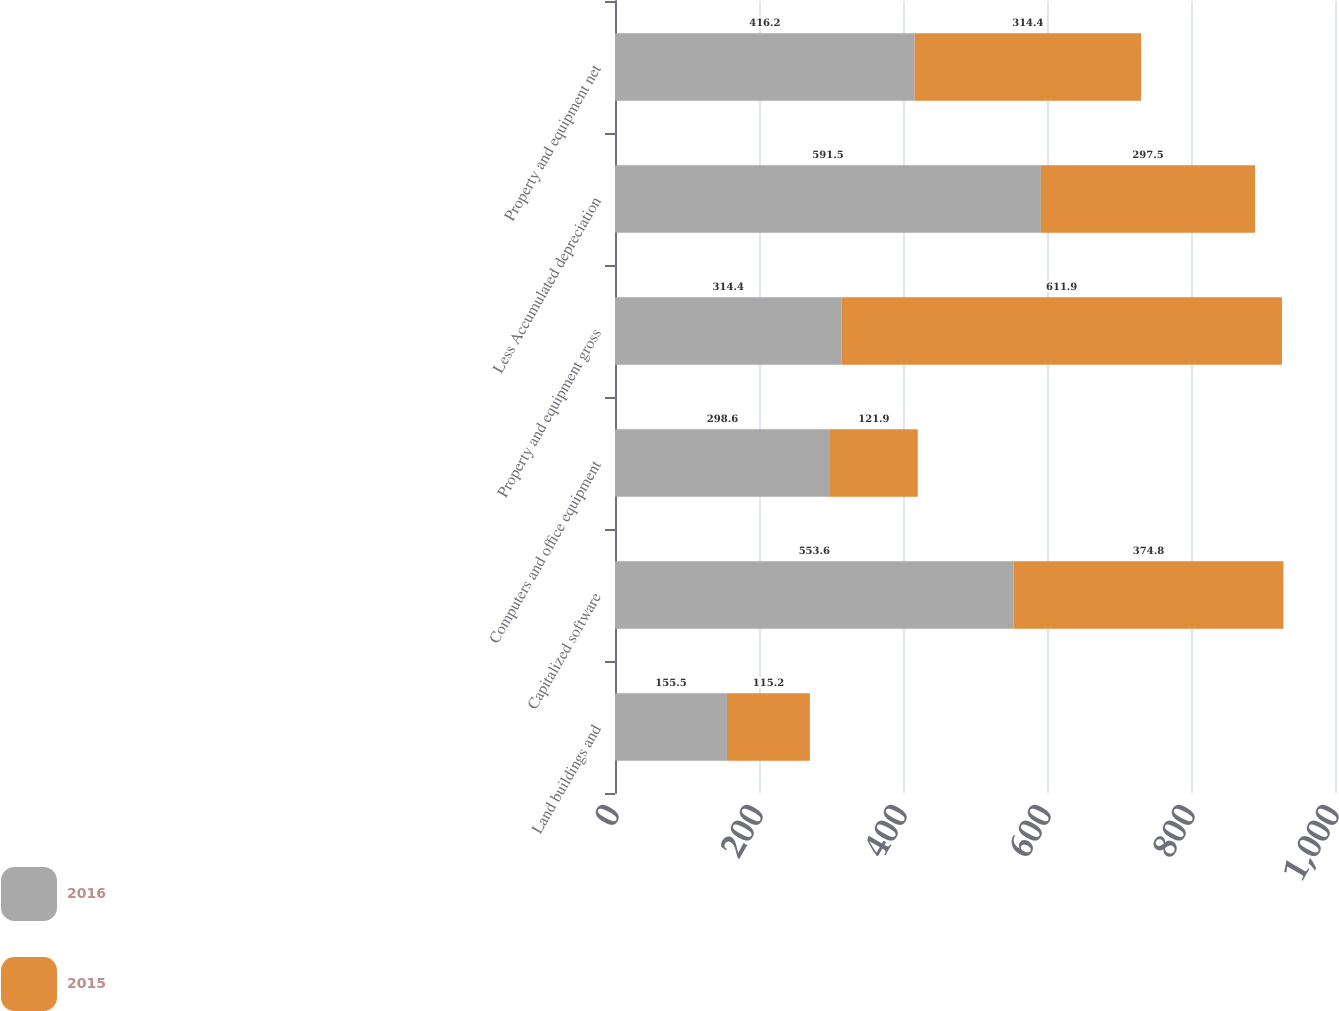Convert chart. <chart><loc_0><loc_0><loc_500><loc_500><stacked_bar_chart><ecel><fcel>Land buildings and<fcel>Capitalized software<fcel>Computers and office equipment<fcel>Property and equipment gross<fcel>Less Accumulated depreciation<fcel>Property and equipment net<nl><fcel>2016<fcel>155.5<fcel>553.6<fcel>298.6<fcel>314.4<fcel>591.5<fcel>416.2<nl><fcel>2015<fcel>115.2<fcel>374.8<fcel>121.9<fcel>611.9<fcel>297.5<fcel>314.4<nl></chart> 